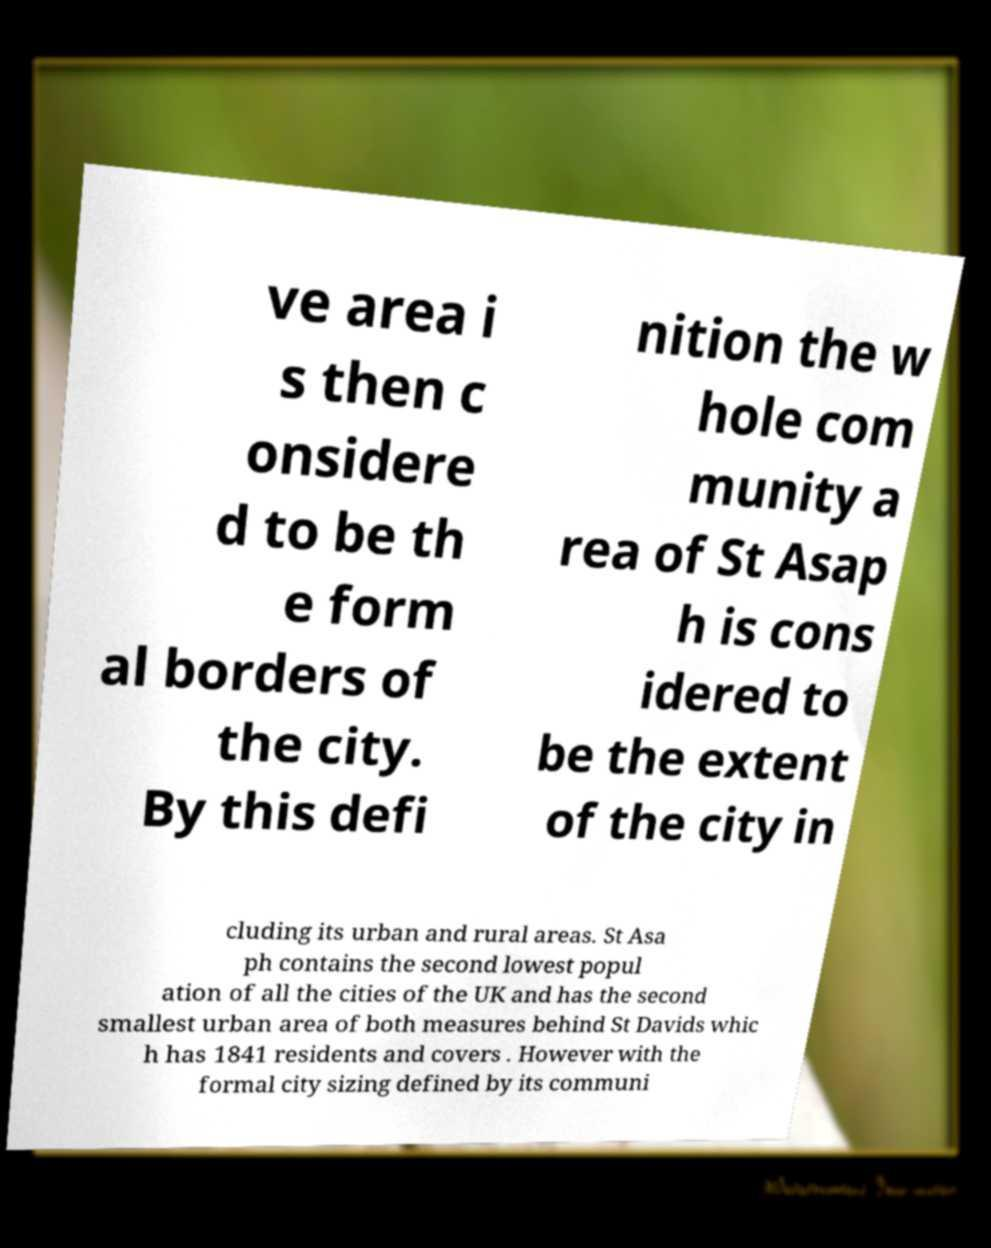Could you extract and type out the text from this image? ve area i s then c onsidere d to be th e form al borders of the city. By this defi nition the w hole com munity a rea of St Asap h is cons idered to be the extent of the city in cluding its urban and rural areas. St Asa ph contains the second lowest popul ation of all the cities of the UK and has the second smallest urban area of both measures behind St Davids whic h has 1841 residents and covers . However with the formal city sizing defined by its communi 